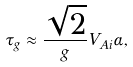Convert formula to latex. <formula><loc_0><loc_0><loc_500><loc_500>\tau _ { g } \approx \frac { \sqrt { 2 } } { g } V _ { A i } \alpha ,</formula> 